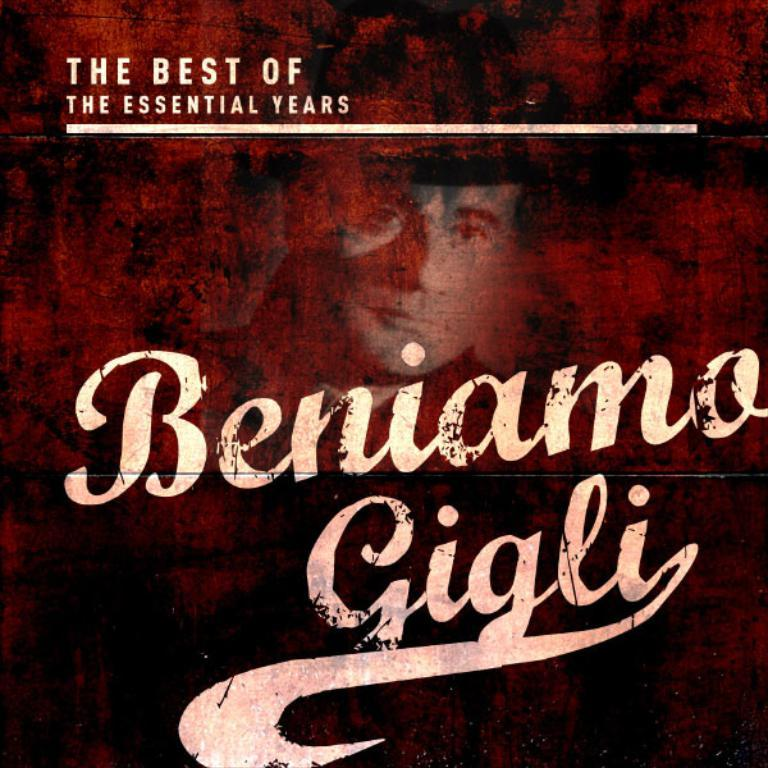<image>
Relay a brief, clear account of the picture shown. An album compilation of Beniamo Gigli that is from the essential years 